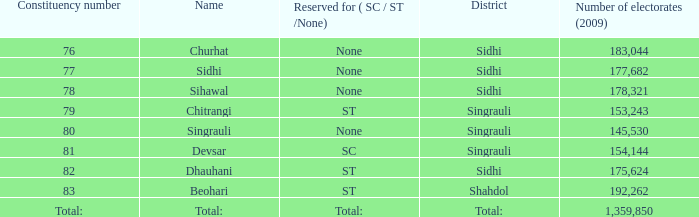What is the highest number of electorates in beohari? 192262.0. 